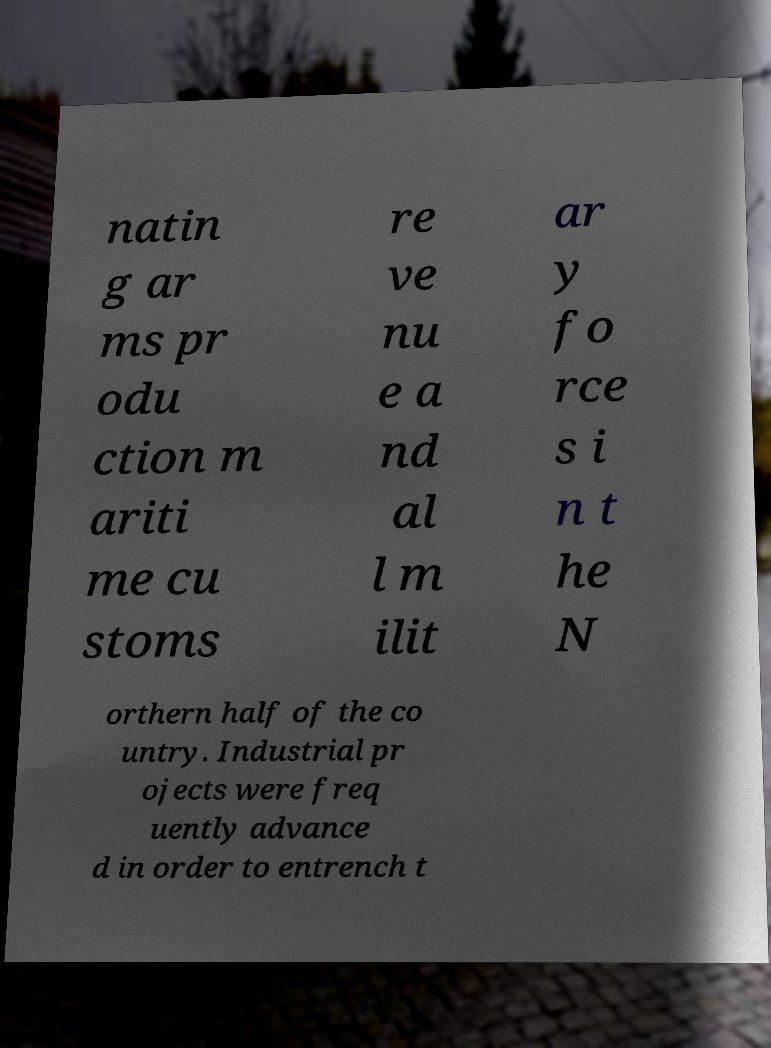Please read and relay the text visible in this image. What does it say? natin g ar ms pr odu ction m ariti me cu stoms re ve nu e a nd al l m ilit ar y fo rce s i n t he N orthern half of the co untry. Industrial pr ojects were freq uently advance d in order to entrench t 